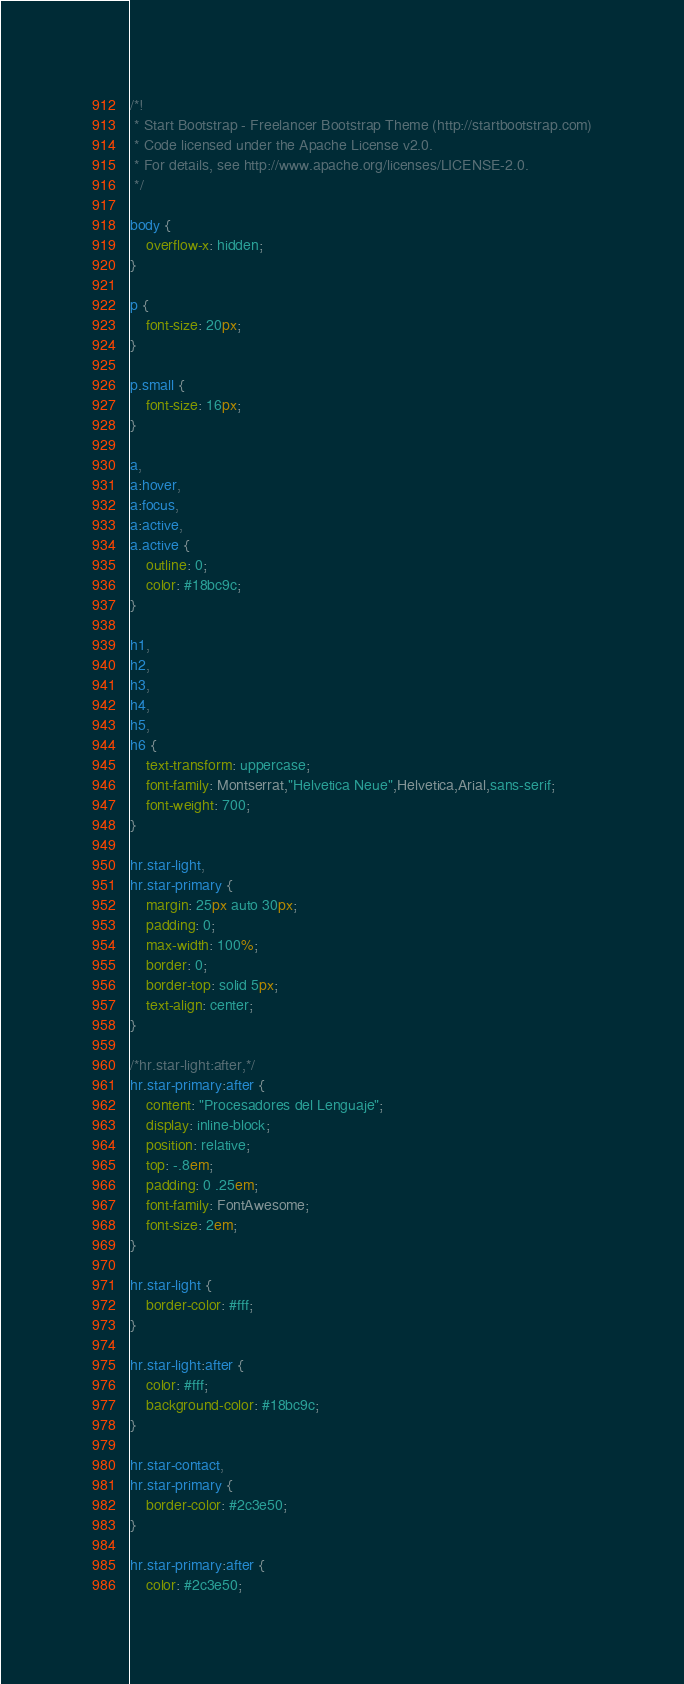Convert code to text. <code><loc_0><loc_0><loc_500><loc_500><_CSS_>/*!
 * Start Bootstrap - Freelancer Bootstrap Theme (http://startbootstrap.com)
 * Code licensed under the Apache License v2.0.
 * For details, see http://www.apache.org/licenses/LICENSE-2.0.
 */

body {
    overflow-x: hidden;
}

p {
    font-size: 20px;
}

p.small {
    font-size: 16px;
}

a,
a:hover,
a:focus,
a:active,
a.active {
    outline: 0;
    color: #18bc9c;
}

h1,
h2,
h3,
h4,
h5,
h6 {
    text-transform: uppercase;
    font-family: Montserrat,"Helvetica Neue",Helvetica,Arial,sans-serif;
    font-weight: 700;
}

hr.star-light,
hr.star-primary {
    margin: 25px auto 30px;
    padding: 0;
    max-width: 100%;
    border: 0;
    border-top: solid 5px;
    text-align: center;
}

/*hr.star-light:after,*/
hr.star-primary:after {
    content: "Procesadores del Lenguaje";
    display: inline-block;
    position: relative;
    top: -.8em;
    padding: 0 .25em;
    font-family: FontAwesome;
    font-size: 2em;
}

hr.star-light {
    border-color: #fff;
}

hr.star-light:after {
    color: #fff;
    background-color: #18bc9c;
}

hr.star-contact,
hr.star-primary {
    border-color: #2c3e50;
}

hr.star-primary:after {
    color: #2c3e50;</code> 